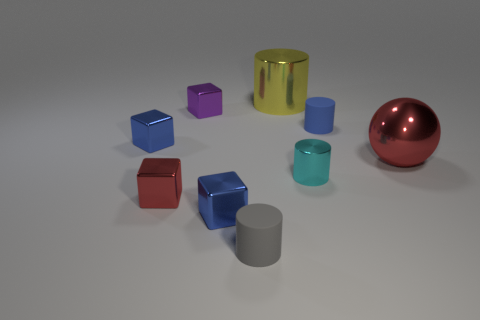What number of tiny blue blocks are the same material as the gray cylinder?
Your answer should be very brief. 0. What number of things are either tiny purple metal blocks or blue rubber cylinders?
Your response must be concise. 2. Is there a big metal ball?
Ensure brevity in your answer.  Yes. What is the material of the blue cube left of the metallic cube that is behind the blue thing on the left side of the tiny purple object?
Offer a very short reply. Metal. Are there fewer tiny red objects behind the small blue matte object than shiny blocks?
Give a very brief answer. Yes. What material is the other thing that is the same size as the yellow shiny object?
Provide a succinct answer. Metal. How big is the block that is both right of the small red block and in front of the small shiny cylinder?
Make the answer very short. Small. The gray matte thing that is the same shape as the big yellow shiny object is what size?
Offer a terse response. Small. How many things are either large brown cubes or small blue shiny cubes behind the big red shiny ball?
Offer a terse response. 1. What shape is the small purple shiny thing?
Offer a very short reply. Cube. 